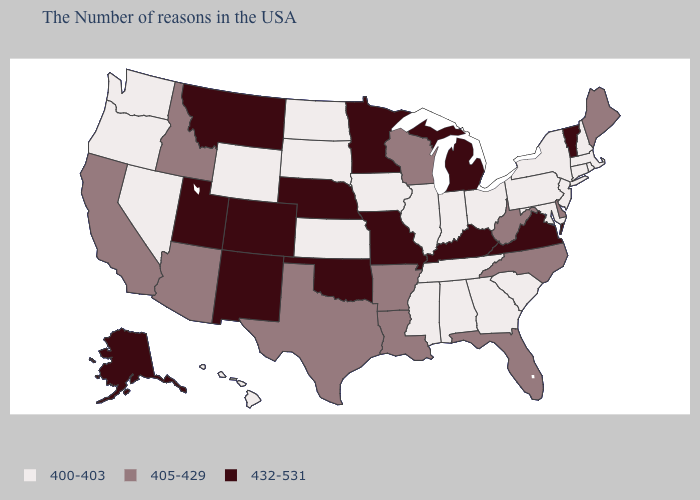What is the value of Arizona?
Give a very brief answer. 405-429. What is the lowest value in the Northeast?
Answer briefly. 400-403. What is the value of Kentucky?
Short answer required. 432-531. What is the value of North Carolina?
Keep it brief. 405-429. What is the lowest value in the USA?
Be succinct. 400-403. What is the value of Connecticut?
Be succinct. 400-403. Does Colorado have the highest value in the USA?
Concise answer only. Yes. Does Wyoming have the lowest value in the USA?
Keep it brief. Yes. Does Oregon have the same value as Hawaii?
Answer briefly. Yes. Does Alaska have the lowest value in the West?
Quick response, please. No. What is the value of Nebraska?
Be succinct. 432-531. What is the lowest value in the USA?
Concise answer only. 400-403. Is the legend a continuous bar?
Answer briefly. No. Name the states that have a value in the range 400-403?
Short answer required. Massachusetts, Rhode Island, New Hampshire, Connecticut, New York, New Jersey, Maryland, Pennsylvania, South Carolina, Ohio, Georgia, Indiana, Alabama, Tennessee, Illinois, Mississippi, Iowa, Kansas, South Dakota, North Dakota, Wyoming, Nevada, Washington, Oregon, Hawaii. 